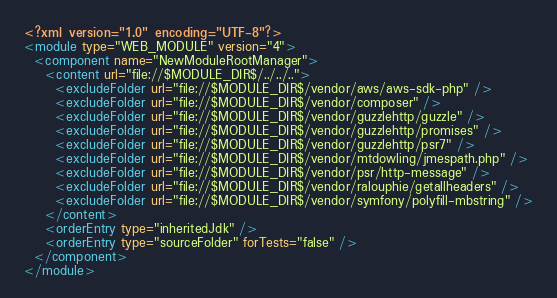Convert code to text. <code><loc_0><loc_0><loc_500><loc_500><_XML_><?xml version="1.0" encoding="UTF-8"?>
<module type="WEB_MODULE" version="4">
  <component name="NewModuleRootManager">
    <content url="file://$MODULE_DIR$/../../..">
      <excludeFolder url="file://$MODULE_DIR$/vendor/aws/aws-sdk-php" />
      <excludeFolder url="file://$MODULE_DIR$/vendor/composer" />
      <excludeFolder url="file://$MODULE_DIR$/vendor/guzzlehttp/guzzle" />
      <excludeFolder url="file://$MODULE_DIR$/vendor/guzzlehttp/promises" />
      <excludeFolder url="file://$MODULE_DIR$/vendor/guzzlehttp/psr7" />
      <excludeFolder url="file://$MODULE_DIR$/vendor/mtdowling/jmespath.php" />
      <excludeFolder url="file://$MODULE_DIR$/vendor/psr/http-message" />
      <excludeFolder url="file://$MODULE_DIR$/vendor/ralouphie/getallheaders" />
      <excludeFolder url="file://$MODULE_DIR$/vendor/symfony/polyfill-mbstring" />
    </content>
    <orderEntry type="inheritedJdk" />
    <orderEntry type="sourceFolder" forTests="false" />
  </component>
</module></code> 